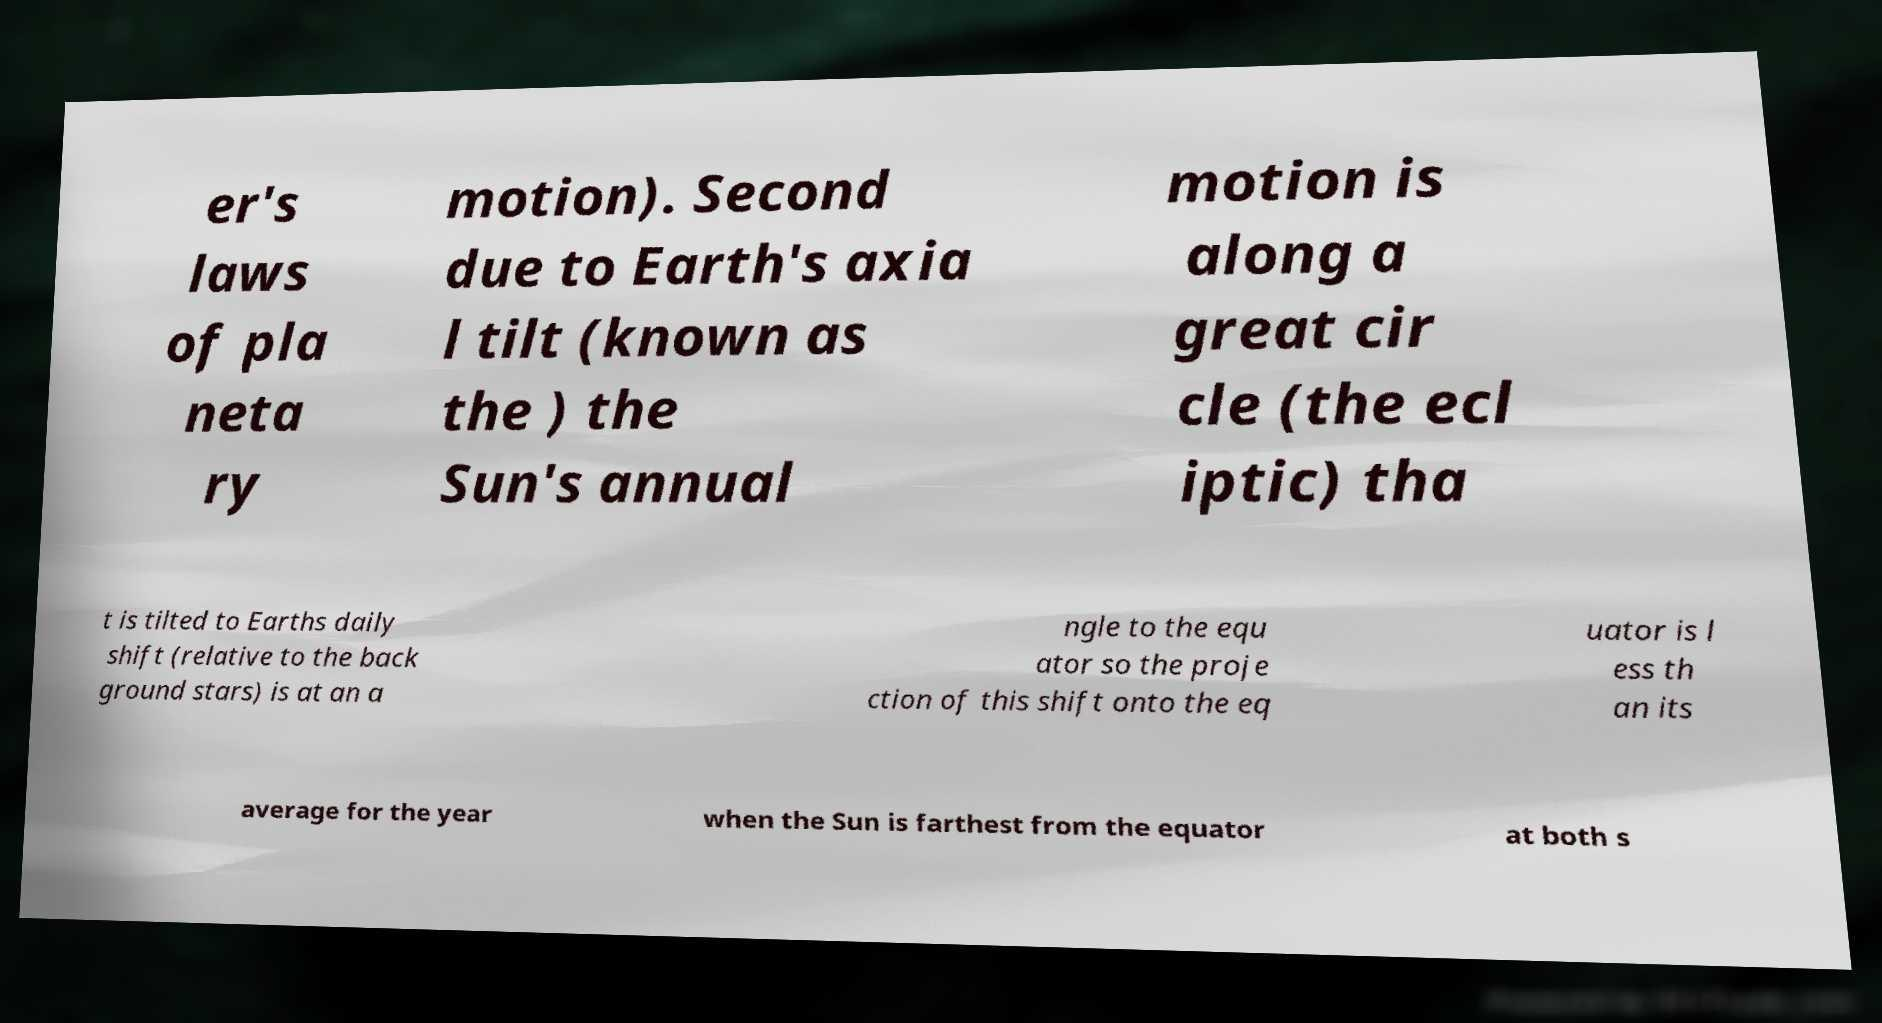Can you accurately transcribe the text from the provided image for me? er's laws of pla neta ry motion). Second due to Earth's axia l tilt (known as the ) the Sun's annual motion is along a great cir cle (the ecl iptic) tha t is tilted to Earths daily shift (relative to the back ground stars) is at an a ngle to the equ ator so the proje ction of this shift onto the eq uator is l ess th an its average for the year when the Sun is farthest from the equator at both s 